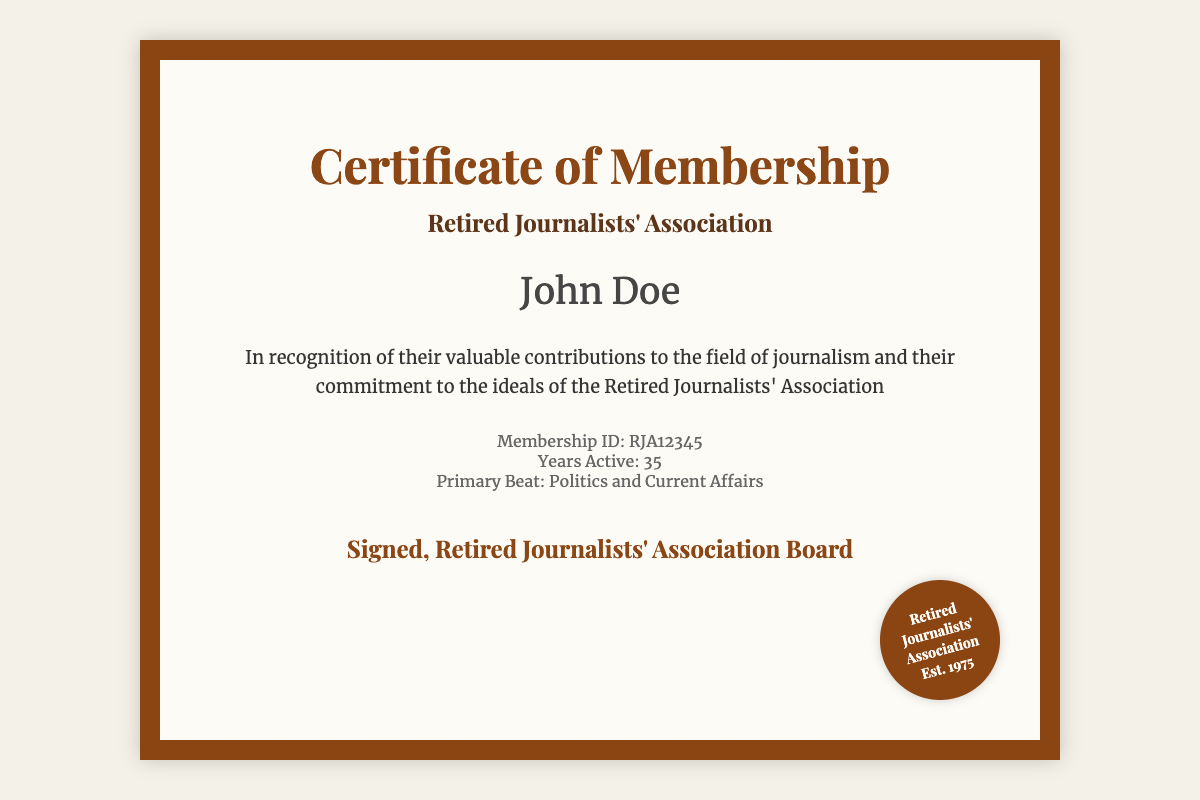what is the title of the document? The title of the document is presented at the top in a prominent font, indicating its purpose.
Answer: Certificate of Membership who is the recipient of the membership certificate? The recipient's name is displayed prominently, indicating who the certificate is awarded to.
Answer: John Doe what is the membership ID? The membership ID is included in the details section of the document, identifying the member uniquely.
Answer: RJA12345 how many years was the recipient active in journalism? The document states the number of years the recipient has been active in journalism.
Answer: 35 what was the recipient's primary beat? The primary focus area of the recipient's journalism career is noted in the details section.
Answer: Politics and Current Affairs who signed the certificate? The signature section of the document indicates who authorized the membership certificate.
Answer: Retired Journalists' Association Board when was the Retired Journalists' Association established? The establishment year is included in the seal section at the bottom of the document.
Answer: 1975 what is the color of the diploma's border? The color of the border surrounding the diploma is a distinct feature noted in its design.
Answer: Brown what type of graphic is used as a background? The visual element that adds to the aesthetic appeal of the document is described in terms of its purpose.
Answer: Watermark 